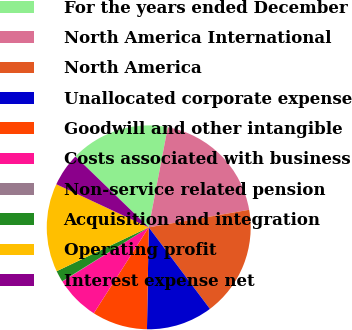<chart> <loc_0><loc_0><loc_500><loc_500><pie_chart><fcel>For the years ended December<fcel>North America International<fcel>North America<fcel>Unallocated corporate expense<fcel>Goodwill and other intangible<fcel>Costs associated with business<fcel>Non-service related pension<fcel>Acquisition and integration<fcel>Operating profit<fcel>Interest expense net<nl><fcel>15.76%<fcel>19.25%<fcel>17.51%<fcel>10.52%<fcel>8.78%<fcel>7.03%<fcel>0.05%<fcel>1.79%<fcel>14.02%<fcel>5.29%<nl></chart> 